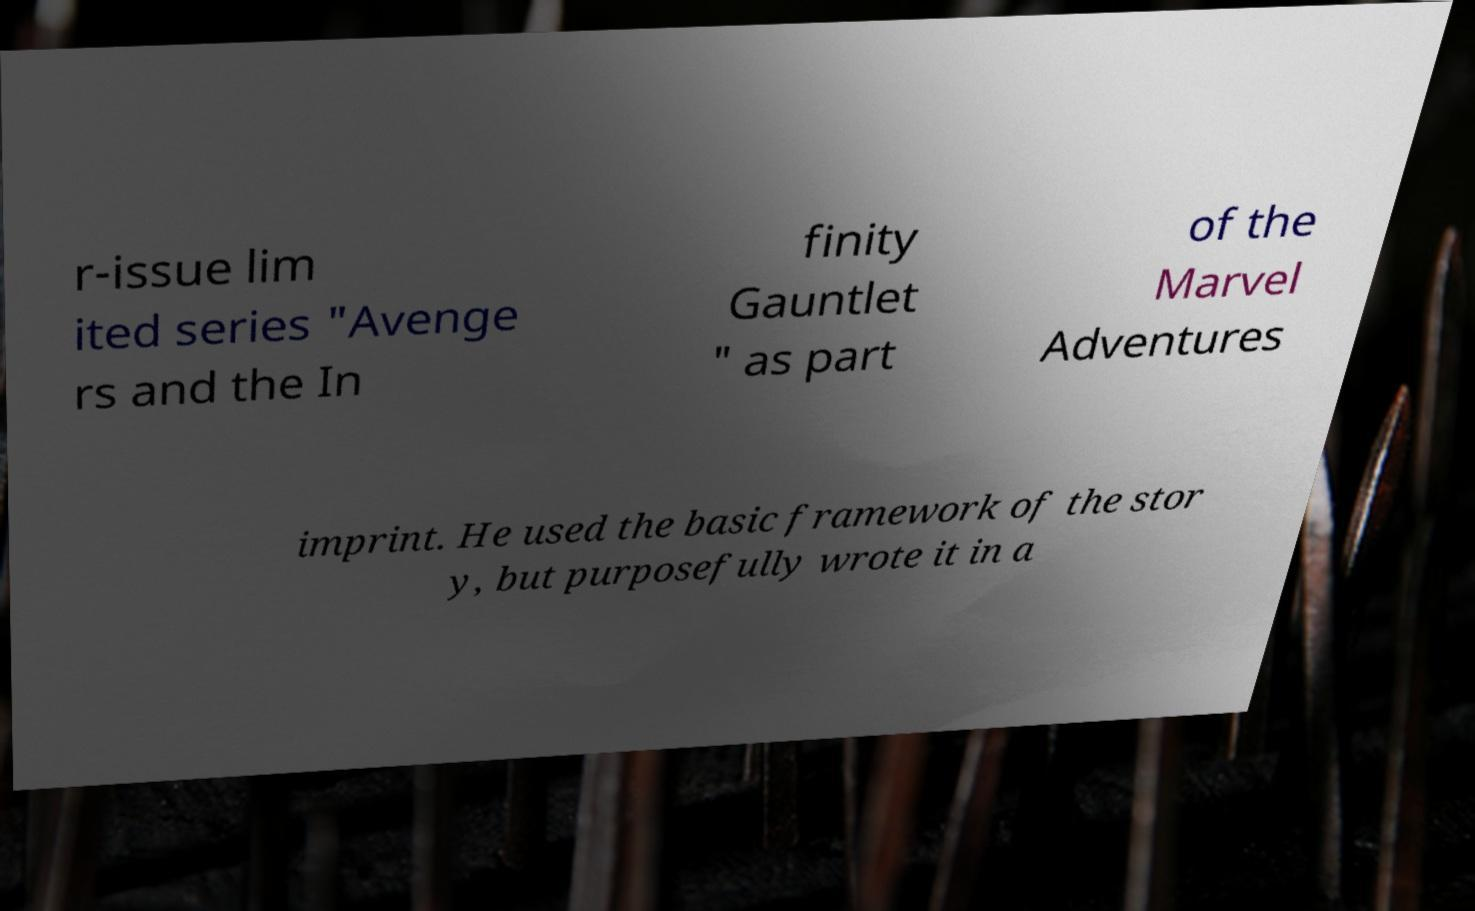Please identify and transcribe the text found in this image. r-issue lim ited series "Avenge rs and the In finity Gauntlet " as part of the Marvel Adventures imprint. He used the basic framework of the stor y, but purposefully wrote it in a 